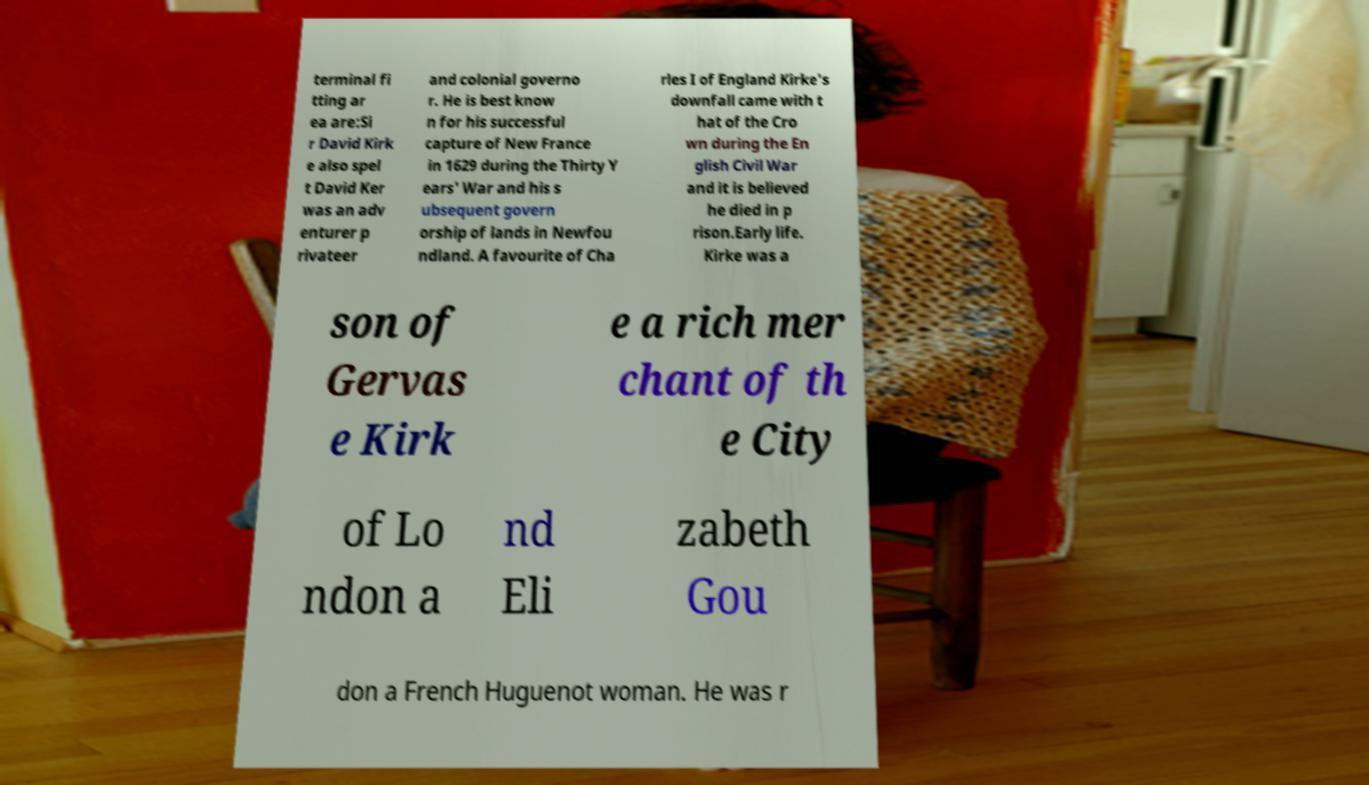Can you read and provide the text displayed in the image?This photo seems to have some interesting text. Can you extract and type it out for me? terminal fi tting ar ea are:Si r David Kirk e also spel t David Ker was an adv enturer p rivateer and colonial governo r. He is best know n for his successful capture of New France in 1629 during the Thirty Y ears' War and his s ubsequent govern orship of lands in Newfou ndland. A favourite of Cha rles I of England Kirke's downfall came with t hat of the Cro wn during the En glish Civil War and it is believed he died in p rison.Early life. Kirke was a son of Gervas e Kirk e a rich mer chant of th e City of Lo ndon a nd Eli zabeth Gou don a French Huguenot woman. He was r 